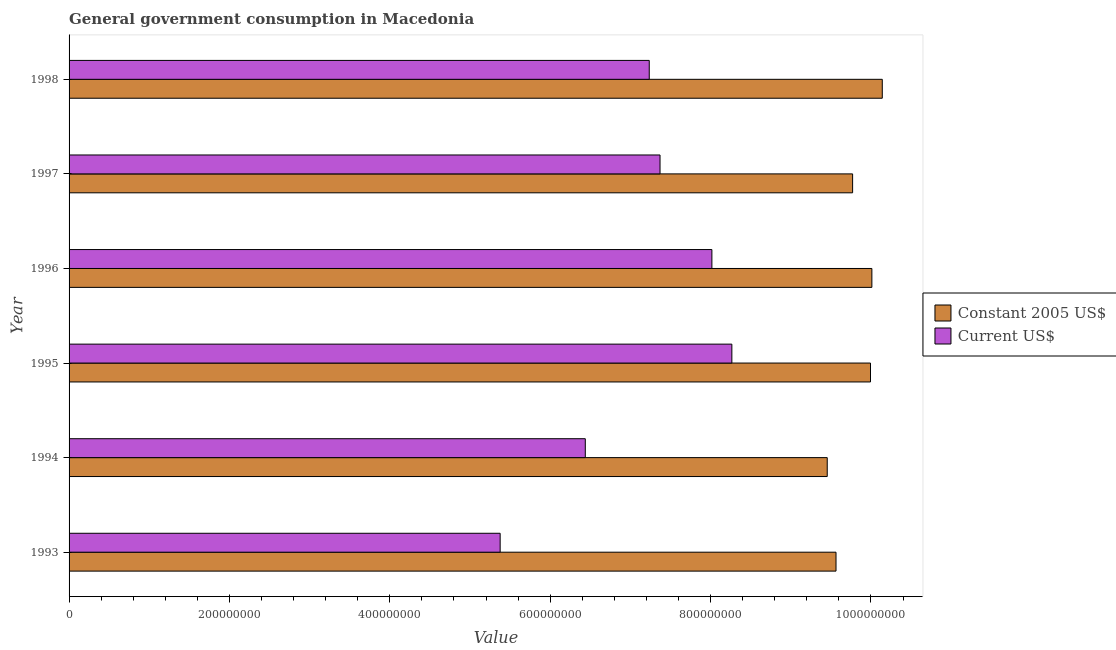How many different coloured bars are there?
Keep it short and to the point. 2. How many groups of bars are there?
Make the answer very short. 6. Are the number of bars per tick equal to the number of legend labels?
Your response must be concise. Yes. Are the number of bars on each tick of the Y-axis equal?
Make the answer very short. Yes. How many bars are there on the 2nd tick from the bottom?
Your answer should be very brief. 2. What is the label of the 3rd group of bars from the top?
Ensure brevity in your answer.  1996. What is the value consumed in current us$ in 1998?
Ensure brevity in your answer.  7.24e+08. Across all years, what is the maximum value consumed in constant 2005 us$?
Keep it short and to the point. 1.01e+09. Across all years, what is the minimum value consumed in current us$?
Provide a short and direct response. 5.38e+08. In which year was the value consumed in constant 2005 us$ maximum?
Provide a short and direct response. 1998. What is the total value consumed in current us$ in the graph?
Provide a short and direct response. 4.27e+09. What is the difference between the value consumed in constant 2005 us$ in 1995 and that in 1997?
Give a very brief answer. 2.23e+07. What is the difference between the value consumed in current us$ in 1994 and the value consumed in constant 2005 us$ in 1996?
Offer a very short reply. -3.57e+08. What is the average value consumed in constant 2005 us$ per year?
Make the answer very short. 9.82e+08. In the year 1997, what is the difference between the value consumed in constant 2005 us$ and value consumed in current us$?
Offer a very short reply. 2.40e+08. What is the ratio of the value consumed in current us$ in 1993 to that in 1994?
Make the answer very short. 0.83. Is the value consumed in current us$ in 1994 less than that in 1998?
Keep it short and to the point. Yes. What is the difference between the highest and the second highest value consumed in current us$?
Provide a short and direct response. 2.49e+07. What is the difference between the highest and the lowest value consumed in constant 2005 us$?
Keep it short and to the point. 6.86e+07. Is the sum of the value consumed in current us$ in 1993 and 1994 greater than the maximum value consumed in constant 2005 us$ across all years?
Your response must be concise. Yes. What does the 2nd bar from the top in 1997 represents?
Provide a succinct answer. Constant 2005 US$. What does the 2nd bar from the bottom in 1998 represents?
Your answer should be compact. Current US$. Are all the bars in the graph horizontal?
Make the answer very short. Yes. How many years are there in the graph?
Keep it short and to the point. 6. What is the difference between two consecutive major ticks on the X-axis?
Offer a terse response. 2.00e+08. Are the values on the major ticks of X-axis written in scientific E-notation?
Provide a succinct answer. No. Does the graph contain any zero values?
Ensure brevity in your answer.  No. Does the graph contain grids?
Offer a very short reply. No. How many legend labels are there?
Offer a very short reply. 2. How are the legend labels stacked?
Provide a succinct answer. Vertical. What is the title of the graph?
Your answer should be very brief. General government consumption in Macedonia. Does "Death rate" appear as one of the legend labels in the graph?
Provide a succinct answer. No. What is the label or title of the X-axis?
Offer a terse response. Value. What is the label or title of the Y-axis?
Provide a succinct answer. Year. What is the Value of Constant 2005 US$ in 1993?
Offer a very short reply. 9.56e+08. What is the Value of Current US$ in 1993?
Your answer should be compact. 5.38e+08. What is the Value in Constant 2005 US$ in 1994?
Keep it short and to the point. 9.45e+08. What is the Value in Current US$ in 1994?
Ensure brevity in your answer.  6.44e+08. What is the Value of Constant 2005 US$ in 1995?
Your response must be concise. 9.99e+08. What is the Value of Current US$ in 1995?
Provide a succinct answer. 8.27e+08. What is the Value of Constant 2005 US$ in 1996?
Provide a short and direct response. 1.00e+09. What is the Value of Current US$ in 1996?
Offer a very short reply. 8.02e+08. What is the Value of Constant 2005 US$ in 1997?
Make the answer very short. 9.77e+08. What is the Value of Current US$ in 1997?
Offer a very short reply. 7.37e+08. What is the Value in Constant 2005 US$ in 1998?
Ensure brevity in your answer.  1.01e+09. What is the Value of Current US$ in 1998?
Keep it short and to the point. 7.24e+08. Across all years, what is the maximum Value of Constant 2005 US$?
Your answer should be compact. 1.01e+09. Across all years, what is the maximum Value of Current US$?
Give a very brief answer. 8.27e+08. Across all years, what is the minimum Value in Constant 2005 US$?
Your answer should be very brief. 9.45e+08. Across all years, what is the minimum Value of Current US$?
Make the answer very short. 5.38e+08. What is the total Value in Constant 2005 US$ in the graph?
Offer a terse response. 5.89e+09. What is the total Value of Current US$ in the graph?
Make the answer very short. 4.27e+09. What is the difference between the Value in Constant 2005 US$ in 1993 and that in 1994?
Make the answer very short. 1.09e+07. What is the difference between the Value of Current US$ in 1993 and that in 1994?
Keep it short and to the point. -1.06e+08. What is the difference between the Value of Constant 2005 US$ in 1993 and that in 1995?
Provide a short and direct response. -4.30e+07. What is the difference between the Value of Current US$ in 1993 and that in 1995?
Make the answer very short. -2.89e+08. What is the difference between the Value of Constant 2005 US$ in 1993 and that in 1996?
Provide a short and direct response. -4.47e+07. What is the difference between the Value in Current US$ in 1993 and that in 1996?
Make the answer very short. -2.64e+08. What is the difference between the Value of Constant 2005 US$ in 1993 and that in 1997?
Your answer should be very brief. -2.07e+07. What is the difference between the Value in Current US$ in 1993 and that in 1997?
Provide a succinct answer. -1.99e+08. What is the difference between the Value of Constant 2005 US$ in 1993 and that in 1998?
Provide a succinct answer. -5.77e+07. What is the difference between the Value of Current US$ in 1993 and that in 1998?
Give a very brief answer. -1.86e+08. What is the difference between the Value in Constant 2005 US$ in 1994 and that in 1995?
Make the answer very short. -5.40e+07. What is the difference between the Value of Current US$ in 1994 and that in 1995?
Make the answer very short. -1.83e+08. What is the difference between the Value of Constant 2005 US$ in 1994 and that in 1996?
Keep it short and to the point. -5.57e+07. What is the difference between the Value in Current US$ in 1994 and that in 1996?
Make the answer very short. -1.58e+08. What is the difference between the Value of Constant 2005 US$ in 1994 and that in 1997?
Ensure brevity in your answer.  -3.16e+07. What is the difference between the Value of Current US$ in 1994 and that in 1997?
Your answer should be compact. -9.32e+07. What is the difference between the Value in Constant 2005 US$ in 1994 and that in 1998?
Keep it short and to the point. -6.86e+07. What is the difference between the Value of Current US$ in 1994 and that in 1998?
Your response must be concise. -7.97e+07. What is the difference between the Value of Constant 2005 US$ in 1995 and that in 1996?
Provide a succinct answer. -1.71e+06. What is the difference between the Value in Current US$ in 1995 and that in 1996?
Provide a succinct answer. 2.49e+07. What is the difference between the Value in Constant 2005 US$ in 1995 and that in 1997?
Offer a terse response. 2.23e+07. What is the difference between the Value of Current US$ in 1995 and that in 1997?
Keep it short and to the point. 8.96e+07. What is the difference between the Value in Constant 2005 US$ in 1995 and that in 1998?
Make the answer very short. -1.47e+07. What is the difference between the Value of Current US$ in 1995 and that in 1998?
Keep it short and to the point. 1.03e+08. What is the difference between the Value of Constant 2005 US$ in 1996 and that in 1997?
Your answer should be very brief. 2.40e+07. What is the difference between the Value in Current US$ in 1996 and that in 1997?
Your response must be concise. 6.47e+07. What is the difference between the Value of Constant 2005 US$ in 1996 and that in 1998?
Make the answer very short. -1.30e+07. What is the difference between the Value in Current US$ in 1996 and that in 1998?
Offer a very short reply. 7.81e+07. What is the difference between the Value in Constant 2005 US$ in 1997 and that in 1998?
Keep it short and to the point. -3.70e+07. What is the difference between the Value in Current US$ in 1997 and that in 1998?
Give a very brief answer. 1.34e+07. What is the difference between the Value of Constant 2005 US$ in 1993 and the Value of Current US$ in 1994?
Offer a very short reply. 3.13e+08. What is the difference between the Value in Constant 2005 US$ in 1993 and the Value in Current US$ in 1995?
Ensure brevity in your answer.  1.30e+08. What is the difference between the Value of Constant 2005 US$ in 1993 and the Value of Current US$ in 1996?
Offer a terse response. 1.55e+08. What is the difference between the Value in Constant 2005 US$ in 1993 and the Value in Current US$ in 1997?
Keep it short and to the point. 2.19e+08. What is the difference between the Value in Constant 2005 US$ in 1993 and the Value in Current US$ in 1998?
Offer a terse response. 2.33e+08. What is the difference between the Value of Constant 2005 US$ in 1994 and the Value of Current US$ in 1995?
Give a very brief answer. 1.19e+08. What is the difference between the Value in Constant 2005 US$ in 1994 and the Value in Current US$ in 1996?
Ensure brevity in your answer.  1.44e+08. What is the difference between the Value of Constant 2005 US$ in 1994 and the Value of Current US$ in 1997?
Offer a very short reply. 2.09e+08. What is the difference between the Value in Constant 2005 US$ in 1994 and the Value in Current US$ in 1998?
Provide a succinct answer. 2.22e+08. What is the difference between the Value in Constant 2005 US$ in 1995 and the Value in Current US$ in 1996?
Provide a succinct answer. 1.98e+08. What is the difference between the Value in Constant 2005 US$ in 1995 and the Value in Current US$ in 1997?
Offer a very short reply. 2.62e+08. What is the difference between the Value of Constant 2005 US$ in 1995 and the Value of Current US$ in 1998?
Offer a very short reply. 2.76e+08. What is the difference between the Value in Constant 2005 US$ in 1996 and the Value in Current US$ in 1997?
Provide a short and direct response. 2.64e+08. What is the difference between the Value of Constant 2005 US$ in 1996 and the Value of Current US$ in 1998?
Provide a succinct answer. 2.78e+08. What is the difference between the Value in Constant 2005 US$ in 1997 and the Value in Current US$ in 1998?
Your response must be concise. 2.54e+08. What is the average Value in Constant 2005 US$ per year?
Give a very brief answer. 9.82e+08. What is the average Value in Current US$ per year?
Ensure brevity in your answer.  7.12e+08. In the year 1993, what is the difference between the Value of Constant 2005 US$ and Value of Current US$?
Give a very brief answer. 4.19e+08. In the year 1994, what is the difference between the Value of Constant 2005 US$ and Value of Current US$?
Provide a succinct answer. 3.02e+08. In the year 1995, what is the difference between the Value in Constant 2005 US$ and Value in Current US$?
Keep it short and to the point. 1.73e+08. In the year 1996, what is the difference between the Value in Constant 2005 US$ and Value in Current US$?
Keep it short and to the point. 2.00e+08. In the year 1997, what is the difference between the Value of Constant 2005 US$ and Value of Current US$?
Provide a short and direct response. 2.40e+08. In the year 1998, what is the difference between the Value in Constant 2005 US$ and Value in Current US$?
Provide a short and direct response. 2.91e+08. What is the ratio of the Value in Constant 2005 US$ in 1993 to that in 1994?
Ensure brevity in your answer.  1.01. What is the ratio of the Value of Current US$ in 1993 to that in 1994?
Offer a terse response. 0.84. What is the ratio of the Value of Current US$ in 1993 to that in 1995?
Your response must be concise. 0.65. What is the ratio of the Value of Constant 2005 US$ in 1993 to that in 1996?
Offer a very short reply. 0.96. What is the ratio of the Value in Current US$ in 1993 to that in 1996?
Offer a terse response. 0.67. What is the ratio of the Value of Constant 2005 US$ in 1993 to that in 1997?
Your answer should be compact. 0.98. What is the ratio of the Value of Current US$ in 1993 to that in 1997?
Offer a terse response. 0.73. What is the ratio of the Value of Constant 2005 US$ in 1993 to that in 1998?
Give a very brief answer. 0.94. What is the ratio of the Value in Current US$ in 1993 to that in 1998?
Offer a terse response. 0.74. What is the ratio of the Value of Constant 2005 US$ in 1994 to that in 1995?
Offer a very short reply. 0.95. What is the ratio of the Value in Current US$ in 1994 to that in 1995?
Provide a succinct answer. 0.78. What is the ratio of the Value of Constant 2005 US$ in 1994 to that in 1996?
Give a very brief answer. 0.94. What is the ratio of the Value of Current US$ in 1994 to that in 1996?
Ensure brevity in your answer.  0.8. What is the ratio of the Value of Constant 2005 US$ in 1994 to that in 1997?
Ensure brevity in your answer.  0.97. What is the ratio of the Value in Current US$ in 1994 to that in 1997?
Offer a very short reply. 0.87. What is the ratio of the Value in Constant 2005 US$ in 1994 to that in 1998?
Provide a succinct answer. 0.93. What is the ratio of the Value in Current US$ in 1994 to that in 1998?
Provide a short and direct response. 0.89. What is the ratio of the Value in Current US$ in 1995 to that in 1996?
Give a very brief answer. 1.03. What is the ratio of the Value in Constant 2005 US$ in 1995 to that in 1997?
Provide a succinct answer. 1.02. What is the ratio of the Value in Current US$ in 1995 to that in 1997?
Your answer should be compact. 1.12. What is the ratio of the Value in Constant 2005 US$ in 1995 to that in 1998?
Offer a terse response. 0.99. What is the ratio of the Value in Current US$ in 1995 to that in 1998?
Your answer should be very brief. 1.14. What is the ratio of the Value of Constant 2005 US$ in 1996 to that in 1997?
Make the answer very short. 1.02. What is the ratio of the Value in Current US$ in 1996 to that in 1997?
Your answer should be very brief. 1.09. What is the ratio of the Value in Constant 2005 US$ in 1996 to that in 1998?
Offer a terse response. 0.99. What is the ratio of the Value of Current US$ in 1996 to that in 1998?
Your response must be concise. 1.11. What is the ratio of the Value in Constant 2005 US$ in 1997 to that in 1998?
Offer a very short reply. 0.96. What is the ratio of the Value in Current US$ in 1997 to that in 1998?
Keep it short and to the point. 1.02. What is the difference between the highest and the second highest Value in Constant 2005 US$?
Your answer should be very brief. 1.30e+07. What is the difference between the highest and the second highest Value in Current US$?
Your answer should be very brief. 2.49e+07. What is the difference between the highest and the lowest Value of Constant 2005 US$?
Ensure brevity in your answer.  6.86e+07. What is the difference between the highest and the lowest Value in Current US$?
Ensure brevity in your answer.  2.89e+08. 